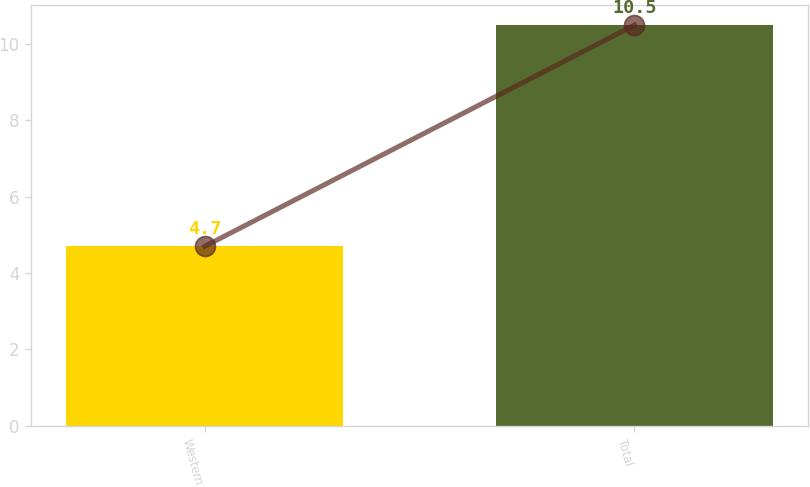Convert chart to OTSL. <chart><loc_0><loc_0><loc_500><loc_500><bar_chart><fcel>Western<fcel>Total<nl><fcel>4.7<fcel>10.5<nl></chart> 